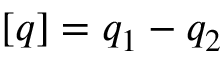Convert formula to latex. <formula><loc_0><loc_0><loc_500><loc_500>[ q ] = q _ { 1 } - q _ { 2 }</formula> 